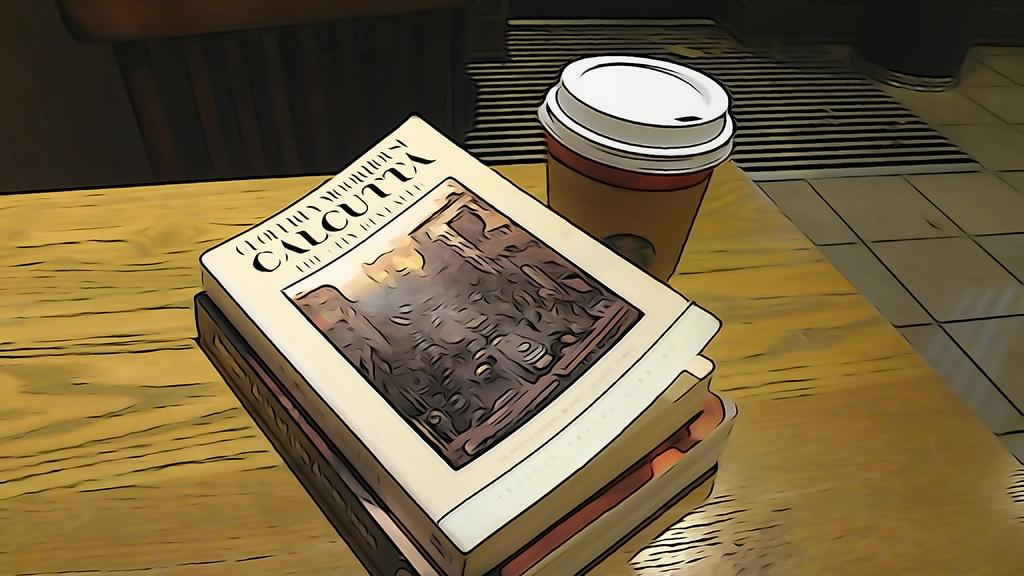<image>
Write a terse but informative summary of the picture. The top book sitting on the table is about Calcutta. 